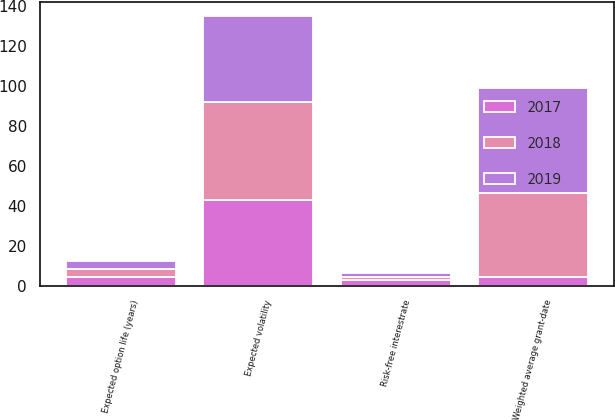Convert chart to OTSL. <chart><loc_0><loc_0><loc_500><loc_500><stacked_bar_chart><ecel><fcel>Weighted average grant-date<fcel>Risk-free interestrate<fcel>Expected option life (years)<fcel>Expected volatility<nl><fcel>2017<fcel>4.14<fcel>2.91<fcel>4.04<fcel>42.8<nl><fcel>2019<fcel>52.34<fcel>1.87<fcel>4.07<fcel>43.5<nl><fcel>2018<fcel>42.4<fcel>1.41<fcel>4.14<fcel>48.9<nl></chart> 